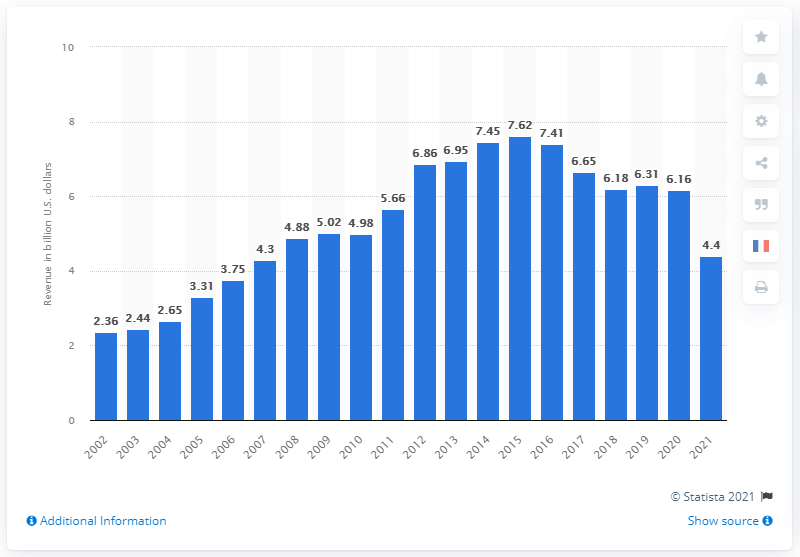Specify some key components in this picture. The total revenue of Polo Ralph Lauren in the financial year that ended March 2021 was 4.4 billion dollars. 